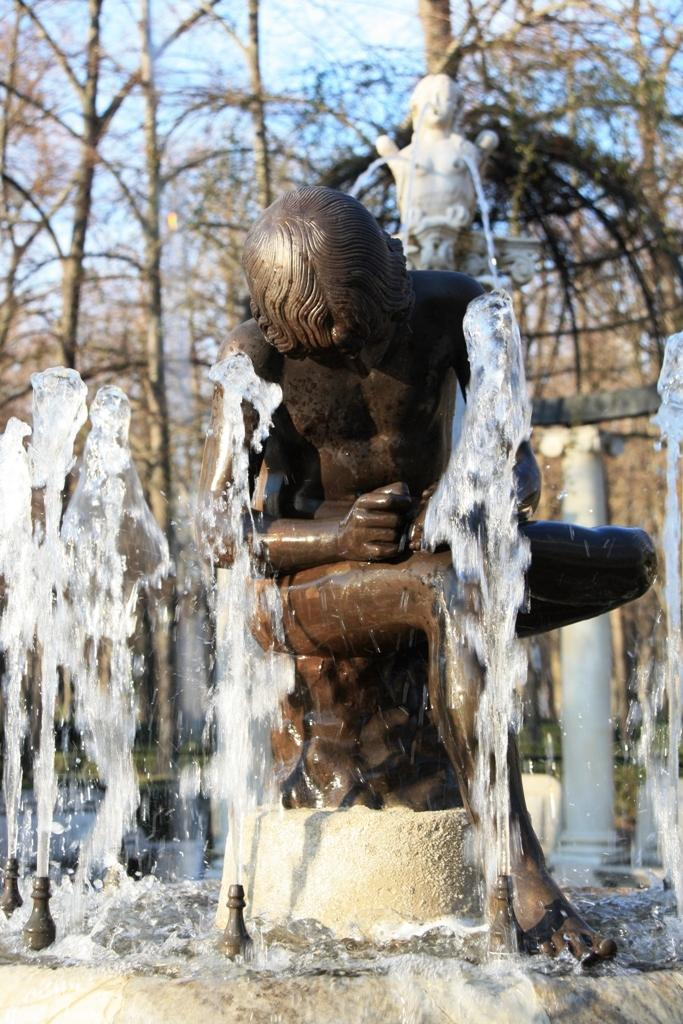What is the main subject in the image? There is a sculpture fountain in the image. What can be seen in the background of the image? There are trees and the sky visible in the background of the image. What type of neck accessory is the sculpture wearing in the image? The sculpture is not a living being and therefore does not wear any apparel or neck accessories. 